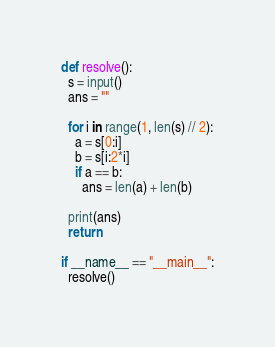<code> <loc_0><loc_0><loc_500><loc_500><_Python_>def resolve():
  s = input()
  ans = ""

  for i in range(1, len(s) // 2):
    a = s[0:i]
    b = s[i:2*i]
    if a == b:
      ans = len(a) + len(b)

  print(ans)
  return

if __name__ == "__main__":
  resolve()
</code> 